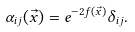Convert formula to latex. <formula><loc_0><loc_0><loc_500><loc_500>\alpha _ { i j } ( \vec { x } ) = e ^ { - 2 f ( \vec { x } ) } \delta _ { i j } .</formula> 